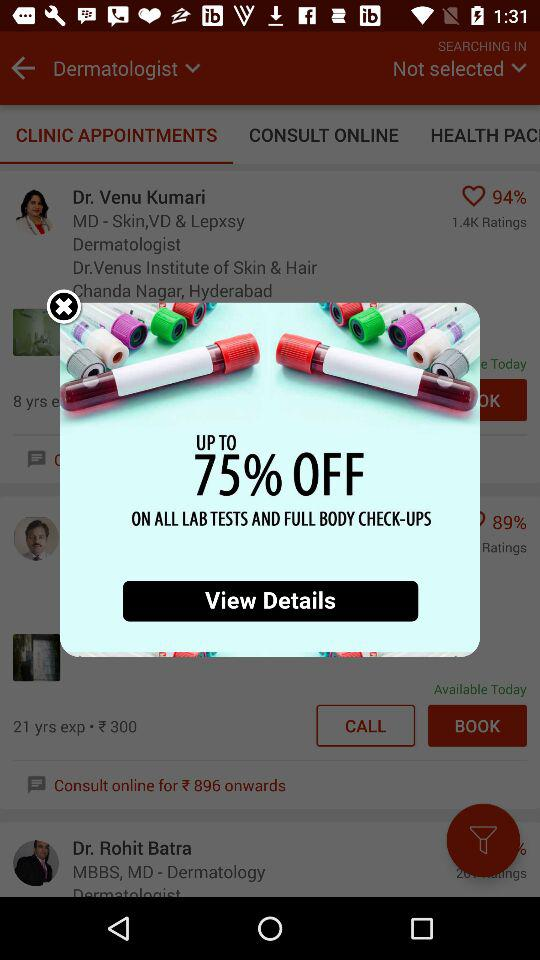What is the percentage off of all lab tests and full body checkups?
Answer the question using a single word or phrase. 75% 